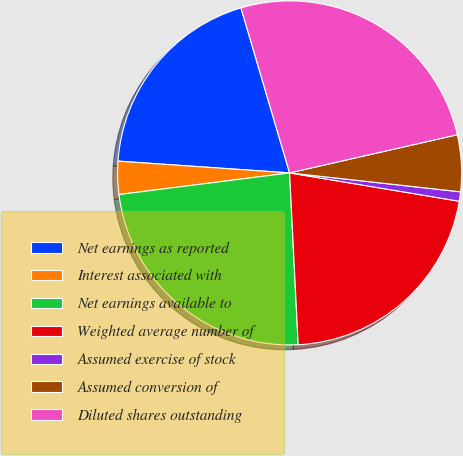<chart> <loc_0><loc_0><loc_500><loc_500><pie_chart><fcel>Net earnings as reported<fcel>Interest associated with<fcel>Net earnings available to<fcel>Weighted average number of<fcel>Assumed exercise of stock<fcel>Assumed conversion of<fcel>Diluted shares outstanding<nl><fcel>19.35%<fcel>3.1%<fcel>23.79%<fcel>21.57%<fcel>0.88%<fcel>5.32%<fcel>26.0%<nl></chart> 